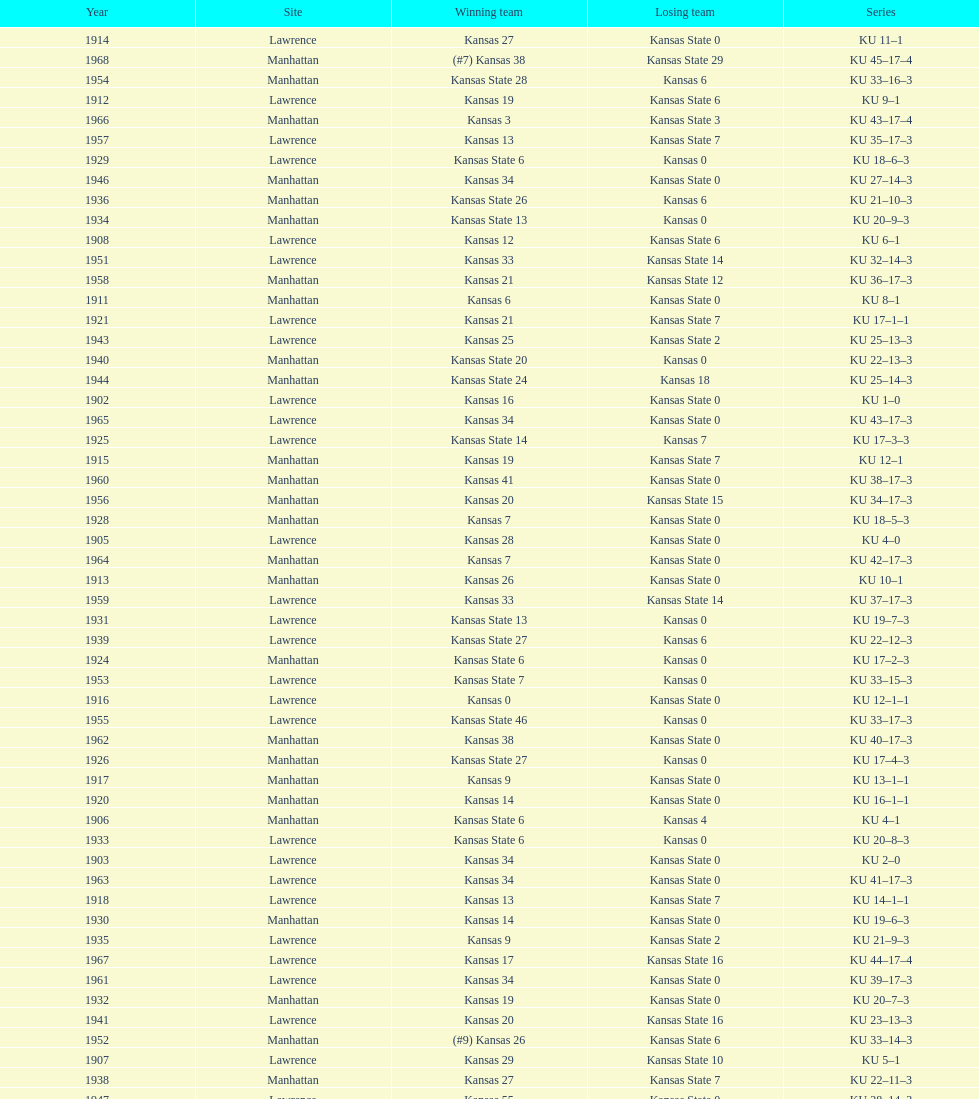Who had the most wins in the 1950's: kansas or kansas state? Kansas. 